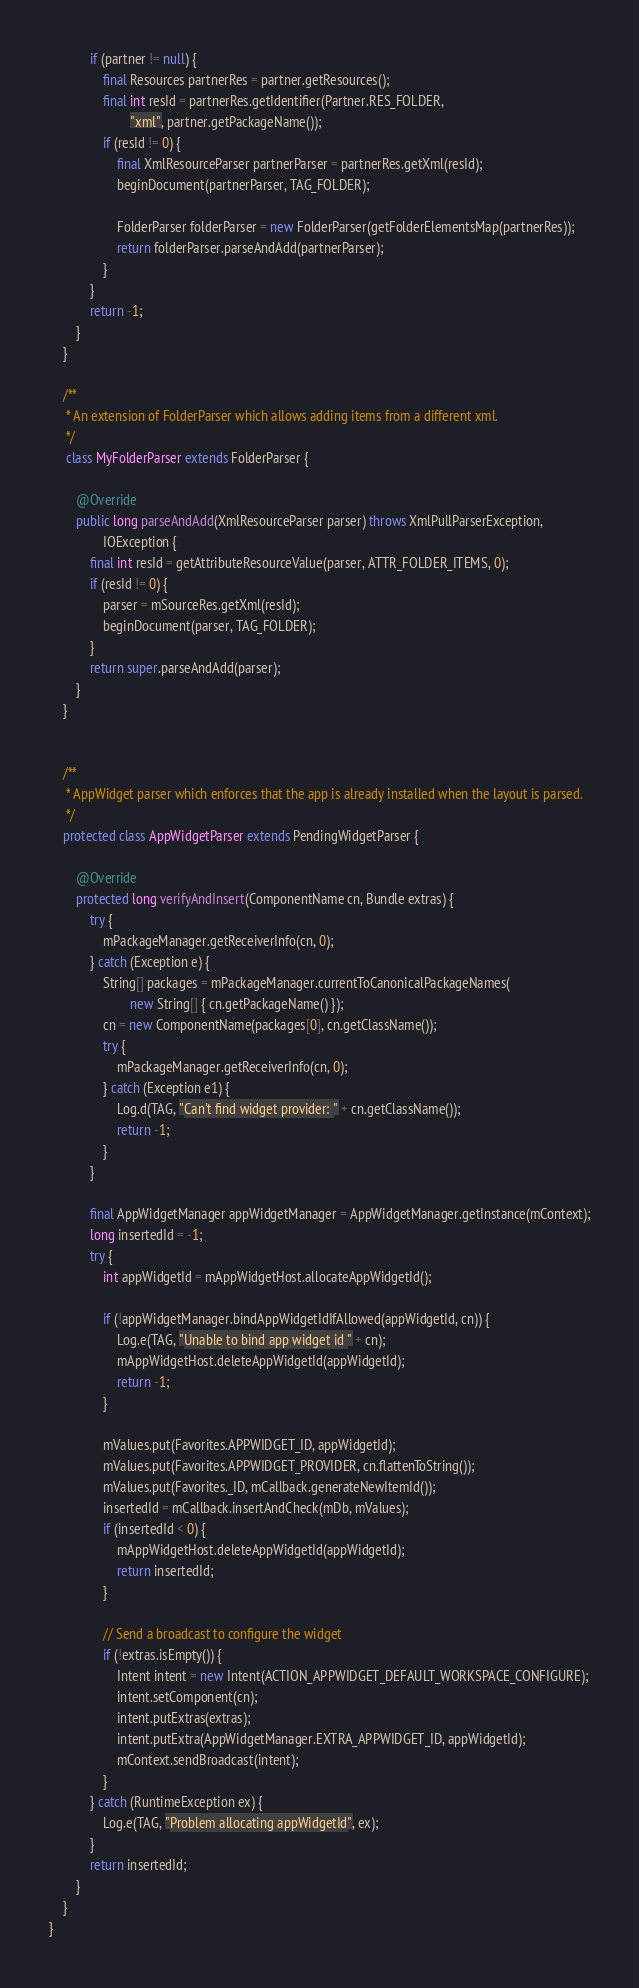Convert code to text. <code><loc_0><loc_0><loc_500><loc_500><_Java_>            if (partner != null) {
                final Resources partnerRes = partner.getResources();
                final int resId = partnerRes.getIdentifier(Partner.RES_FOLDER,
                        "xml", partner.getPackageName());
                if (resId != 0) {
                    final XmlResourceParser partnerParser = partnerRes.getXml(resId);
                    beginDocument(partnerParser, TAG_FOLDER);

                    FolderParser folderParser = new FolderParser(getFolderElementsMap(partnerRes));
                    return folderParser.parseAndAdd(partnerParser);
                }
            }
            return -1;
        }
    }

    /**
     * An extension of FolderParser which allows adding items from a different xml.
     */
     class MyFolderParser extends FolderParser {

        @Override
        public long parseAndAdd(XmlResourceParser parser) throws XmlPullParserException,
                IOException {
            final int resId = getAttributeResourceValue(parser, ATTR_FOLDER_ITEMS, 0);
            if (resId != 0) {
                parser = mSourceRes.getXml(resId);
                beginDocument(parser, TAG_FOLDER);
            }
            return super.parseAndAdd(parser);
        }
    }


    /**
     * AppWidget parser which enforces that the app is already installed when the layout is parsed.
     */
    protected class AppWidgetParser extends PendingWidgetParser {

        @Override
        protected long verifyAndInsert(ComponentName cn, Bundle extras) {
            try {
                mPackageManager.getReceiverInfo(cn, 0);
            } catch (Exception e) {
                String[] packages = mPackageManager.currentToCanonicalPackageNames(
                        new String[] { cn.getPackageName() });
                cn = new ComponentName(packages[0], cn.getClassName());
                try {
                    mPackageManager.getReceiverInfo(cn, 0);
                } catch (Exception e1) {
                    Log.d(TAG, "Can't find widget provider: " + cn.getClassName());
                    return -1;
                }
            }

            final AppWidgetManager appWidgetManager = AppWidgetManager.getInstance(mContext);
            long insertedId = -1;
            try {
                int appWidgetId = mAppWidgetHost.allocateAppWidgetId();

                if (!appWidgetManager.bindAppWidgetIdIfAllowed(appWidgetId, cn)) {
                    Log.e(TAG, "Unable to bind app widget id " + cn);
                    mAppWidgetHost.deleteAppWidgetId(appWidgetId);
                    return -1;
                }

                mValues.put(Favorites.APPWIDGET_ID, appWidgetId);
                mValues.put(Favorites.APPWIDGET_PROVIDER, cn.flattenToString());
                mValues.put(Favorites._ID, mCallback.generateNewItemId());
                insertedId = mCallback.insertAndCheck(mDb, mValues);
                if (insertedId < 0) {
                    mAppWidgetHost.deleteAppWidgetId(appWidgetId);
                    return insertedId;
                }

                // Send a broadcast to configure the widget
                if (!extras.isEmpty()) {
                    Intent intent = new Intent(ACTION_APPWIDGET_DEFAULT_WORKSPACE_CONFIGURE);
                    intent.setComponent(cn);
                    intent.putExtras(extras);
                    intent.putExtra(AppWidgetManager.EXTRA_APPWIDGET_ID, appWidgetId);
                    mContext.sendBroadcast(intent);
                }
            } catch (RuntimeException ex) {
                Log.e(TAG, "Problem allocating appWidgetId", ex);
            }
            return insertedId;
        }
    }
}
</code> 